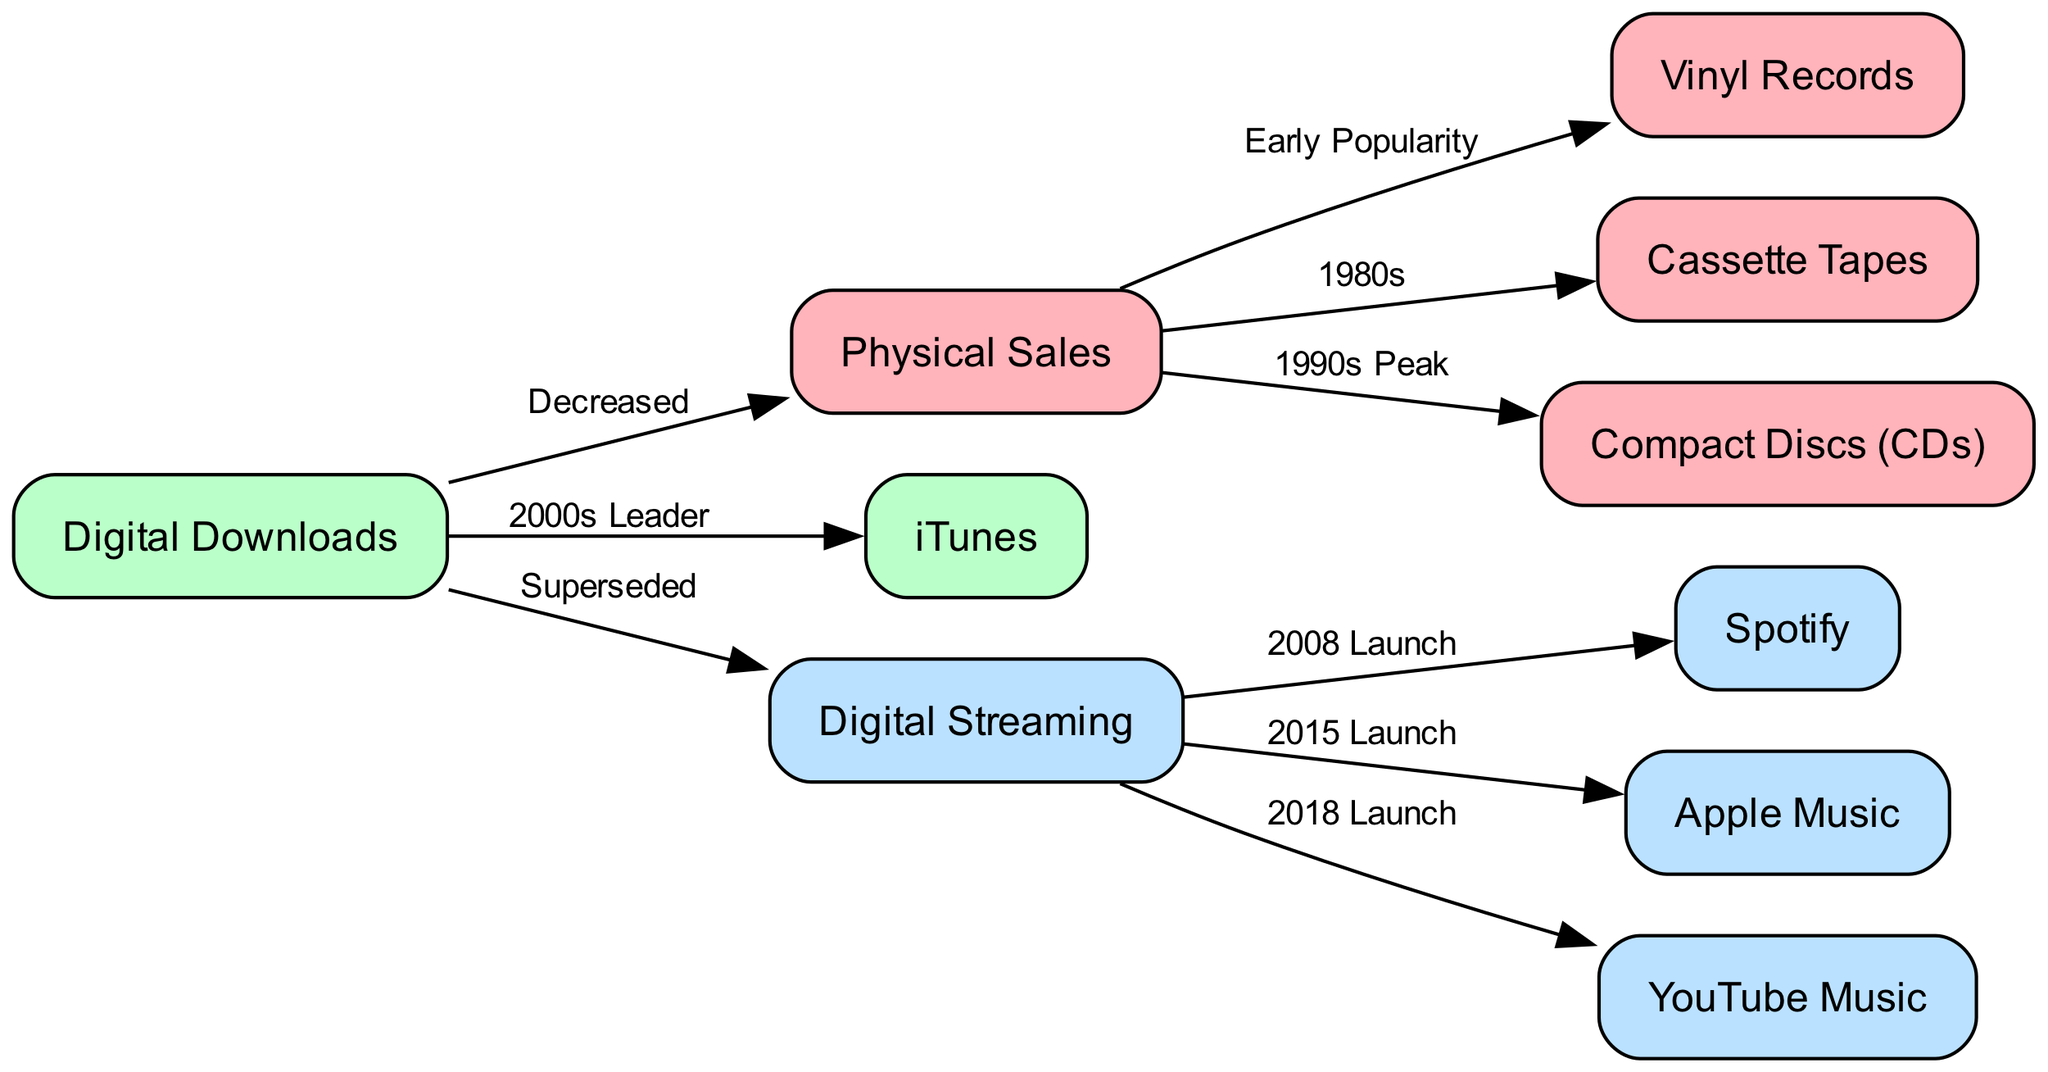What distribution method peaked in the 1990s? In the diagram, the node labeled "Compact Discs (CDs)" is connected to "Physical Sales" with the label "1990s Peak," indicating that CDs were the peak distribution method during that decade.
Answer: Compact Discs (CDs) How many types of physical sales are mentioned in the diagram? The diagram lists three types of physical sales: "Vinyl Records," "Cassette Tapes," and "Compact Discs (CDs)." Therefore, by counting these nodes under "Physical Sales," we find three types.
Answer: 3 What launched in 2015 according to the diagram? The node labeled "Apple Music" is connected to "Streaming" with the label "2015 Launch," indicating that it was the streaming service that launched in 2015.
Answer: Apple Music Which distribution method decreased due to digital downloads? The edge labeled "Decreased" connects "Digital Downloads" to "Physical Sales," showing that physical sales have decreased as a direct result of the rise of digital downloads.
Answer: Physical Sales What is the earliest type of physical sales mentioned? The diagram shows an edge from "Physical Sales" to "Vinyl Records" with the label "Early Popularity," indicating that vinyl records were the earliest type mentioned in the context of physical sales.
Answer: Vinyl Records Which digital distribution method was labeled as the leader in the 2000s? "iTunes" is connected to "Digital Downloads" with the label "2000s Leader," denoting that iTunes was the leading digital distribution method during that period.
Answer: iTunes How is digital downloads related to streaming in this diagram? The edge labeled "Superseded" connects "Digital Downloads" to "Streaming," meaning that digital downloads were replaced in prominence by streaming as a method of music distribution.
Answer: Superseded What is the launch year for Spotify? The edge labeled "2008 Launch" links "Streaming" to "Spotify," indicating that Spotify was launched in the year 2008.
Answer: 2008 